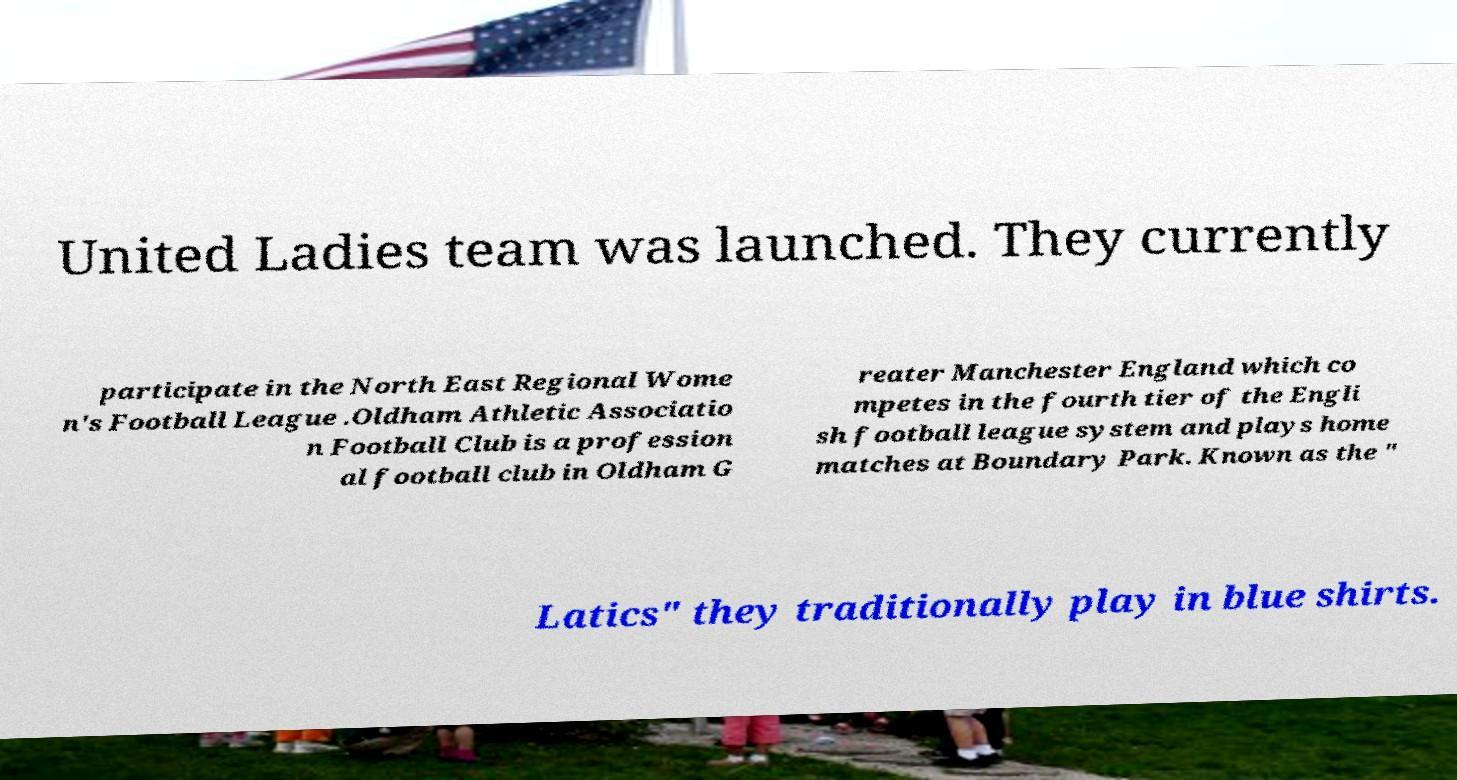Please identify and transcribe the text found in this image. United Ladies team was launched. They currently participate in the North East Regional Wome n's Football League .Oldham Athletic Associatio n Football Club is a profession al football club in Oldham G reater Manchester England which co mpetes in the fourth tier of the Engli sh football league system and plays home matches at Boundary Park. Known as the " Latics" they traditionally play in blue shirts. 